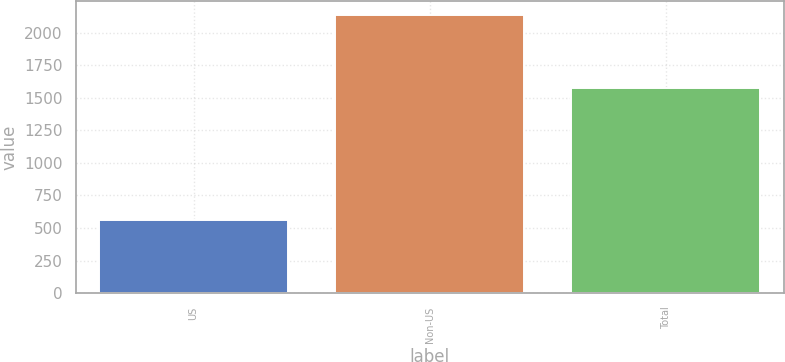Convert chart to OTSL. <chart><loc_0><loc_0><loc_500><loc_500><bar_chart><fcel>US<fcel>Non-US<fcel>Total<nl><fcel>560<fcel>2136<fcel>1576<nl></chart> 